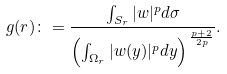<formula> <loc_0><loc_0><loc_500><loc_500>g ( r ) \colon = \frac { \int _ { S _ { r } } | w | ^ { p } d \sigma } { \left ( \int _ { \Omega _ { r } } | w ( y ) | ^ { p } d y \right ) ^ { \, \frac { p + 2 } { 2 p } } } .</formula> 